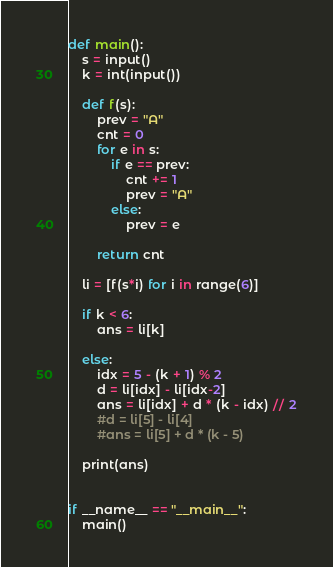Convert code to text. <code><loc_0><loc_0><loc_500><loc_500><_Python_>def main():
    s = input()
    k = int(input())

    def f(s):
        prev = "A"
        cnt = 0
        for e in s:
            if e == prev:
                cnt += 1
                prev = "A"
            else:
                prev = e

        return cnt

    li = [f(s*i) for i in range(6)]

    if k < 6:
        ans = li[k]

    else:
        idx = 5 - (k + 1) % 2
        d = li[idx] - li[idx-2]
        ans = li[idx] + d * (k - idx) // 2
        #d = li[5] - li[4]
        #ans = li[5] + d * (k - 5)

    print(ans)


if __name__ == "__main__":
    main()
</code> 